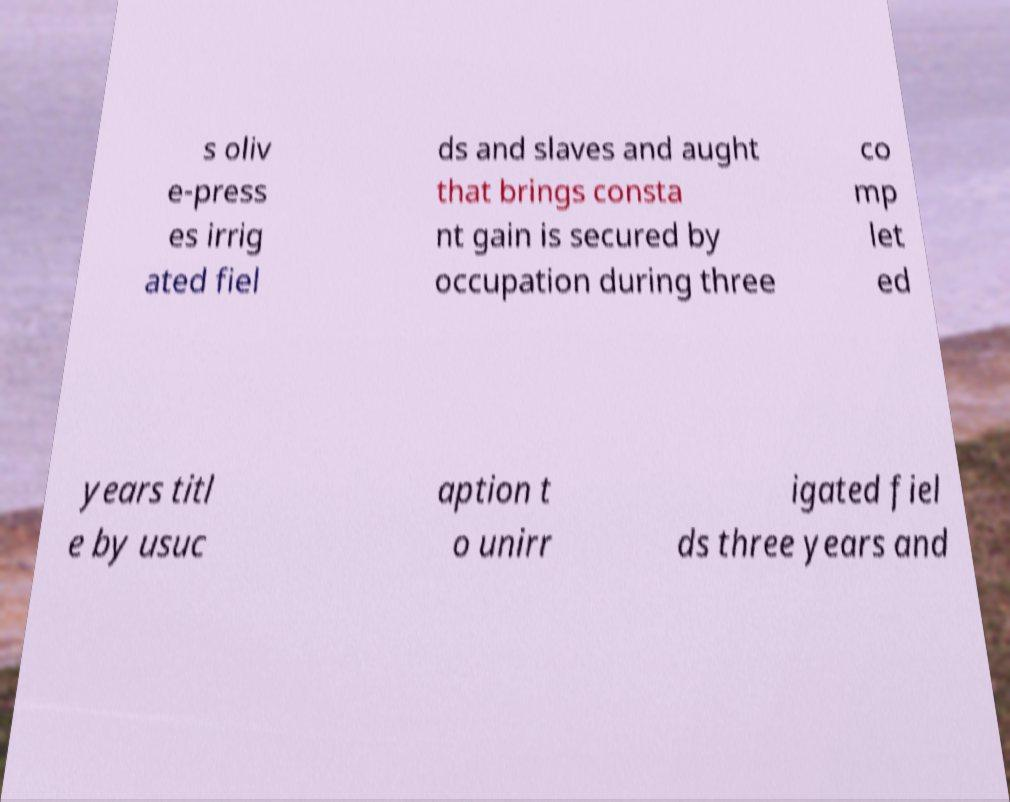Could you assist in decoding the text presented in this image and type it out clearly? s oliv e-press es irrig ated fiel ds and slaves and aught that brings consta nt gain is secured by occupation during three co mp let ed years titl e by usuc aption t o unirr igated fiel ds three years and 